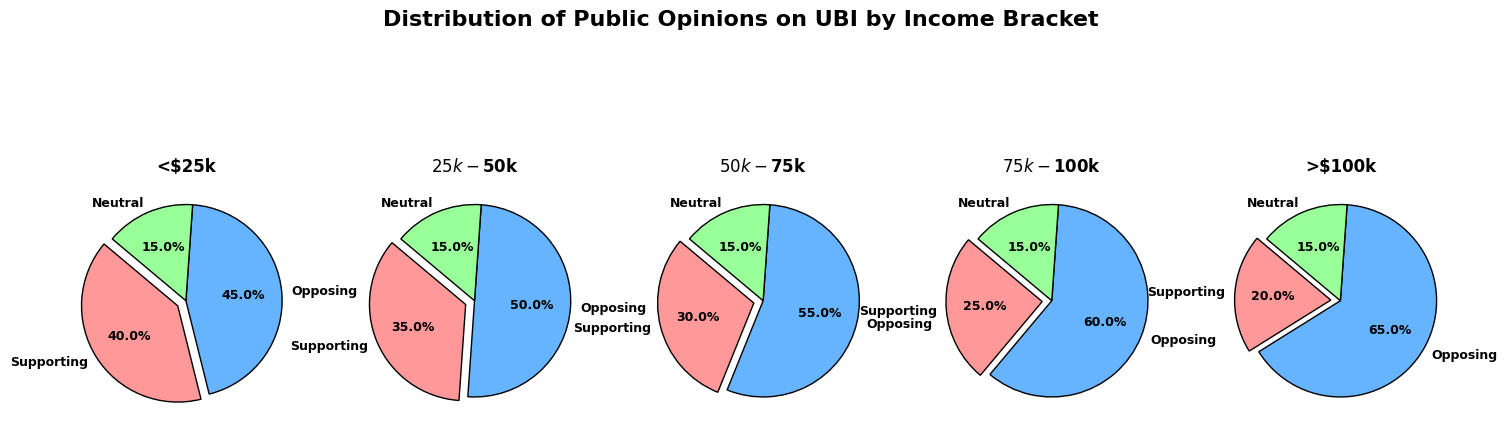What percentage of people earning more than $100k are neutral about UBI? We look at the ">$100k" income bracket and find the segment labeled "Neutral." The pie chart indicates this segment's value.
Answer: 15% Compare the support for UBI among people earning less than $25k and those earning $75k-$100k. We look at the segments labeled "Supporting" in the pie charts for the "<$25k" and "$75k-$100k" income brackets. The values are 40% and 25%, respectively.
Answer: 40% vs. 25% Which income bracket has the highest percentage opposing UBI? We examine all segments labeled "Opposing" across each income bracket. The "$100k" bracket has the highest percentage with 65%.
Answer: >$100k What's the difference in support for UBI between income brackets $50k-$75k and $25k-$50k? We find the "Supporting" segments for "$50k-$75k" (30%) and "$25k-$50k" (35%), then calculate the difference: 35% - 30% = 5%.
Answer: 5% What is the total percentage of people who are neutral about UBI across all income brackets? Each income bracket shows 15% neutral. With 5 brackets, we sum 15% five times: 15% * 5 = 75%.
Answer: 75% Which income bracket shows the least support for UBI? We check the "Supporting" segments across all pie charts. The "> $100k" bracket shows the least support with 20%.
Answer: >$100k How does opposition to UBI change as income increases from less than $25k to more than $100k? Observing the sequence of "Opposing" segments: "<$25k" (45%), "$25k-$50k" (50%), "$50k-$75k" (55%), "$75k-$100k" (60%), "> $100k" (65%). The opposition consistently increases.
Answer: Increases 